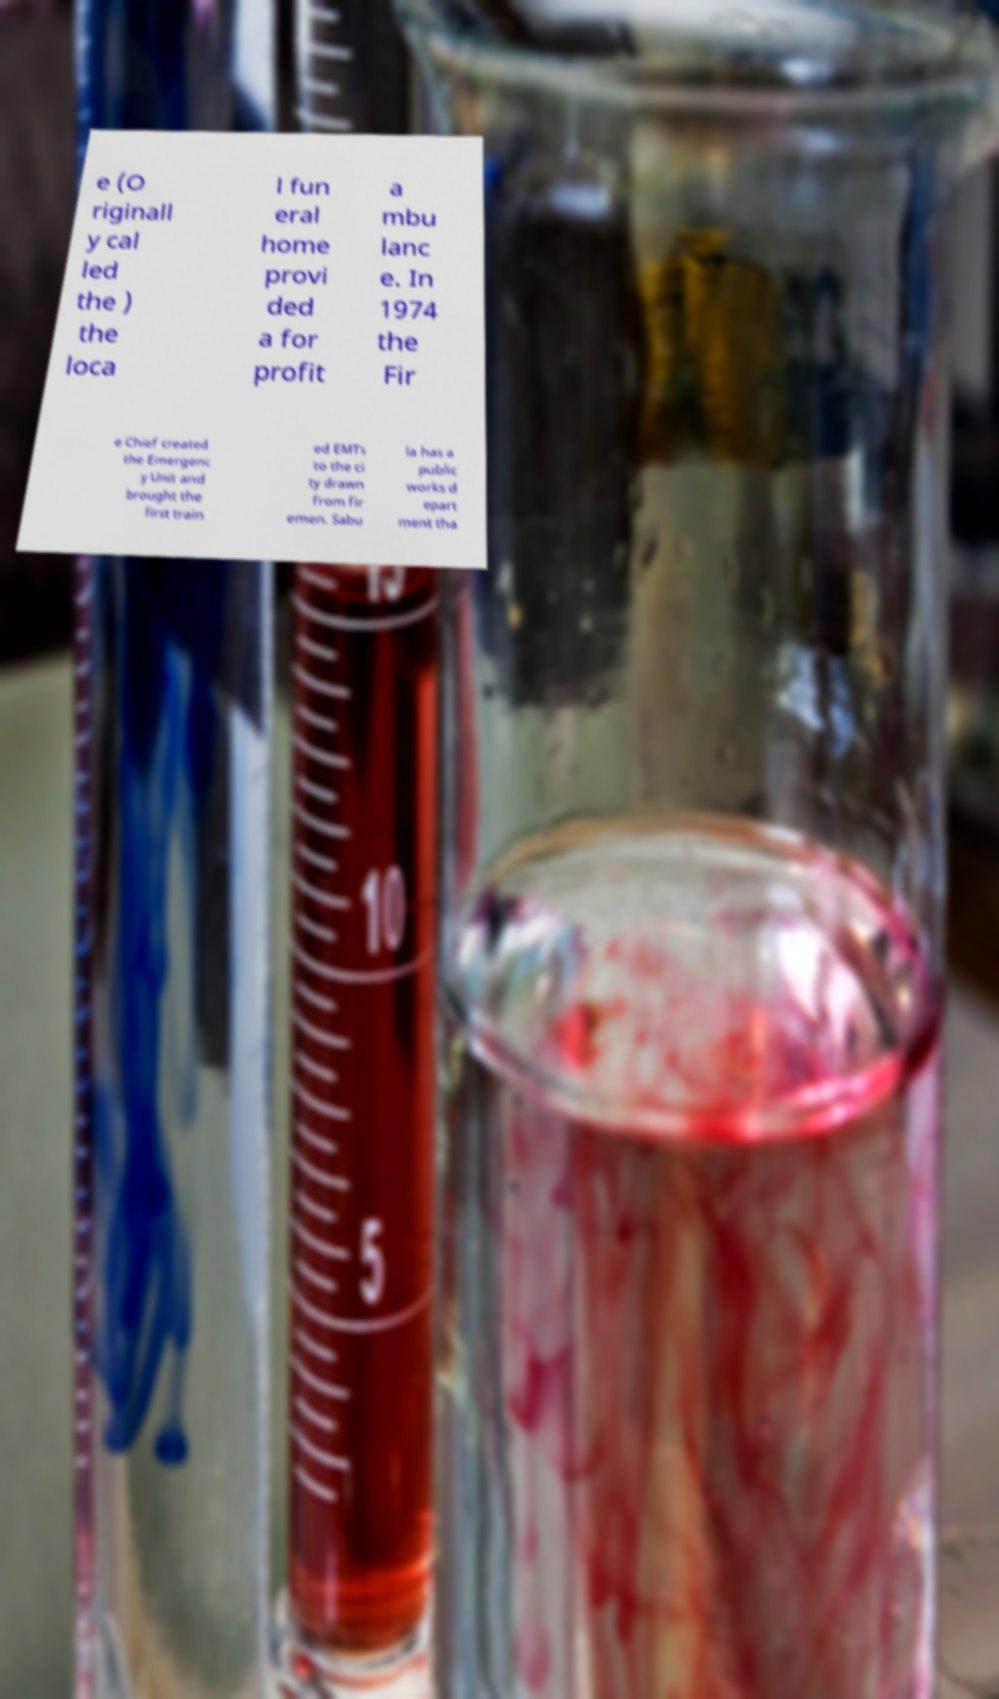For documentation purposes, I need the text within this image transcribed. Could you provide that? e (O riginall y cal led the ) the loca l fun eral home provi ded a for profit a mbu lanc e. In 1974 the Fir e Chief created the Emergenc y Unit and brought the first train ed EMTs to the ci ty drawn from fir emen. Sabu la has a public works d epart ment tha 